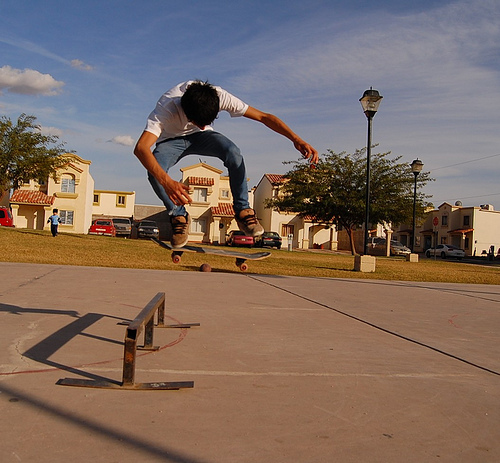How many coca-cola bottles are there? There are no Coca-Cola bottles visible in the image. The focus of the image is a person doing a skateboarding trick near a lamp post and a metal rail. 